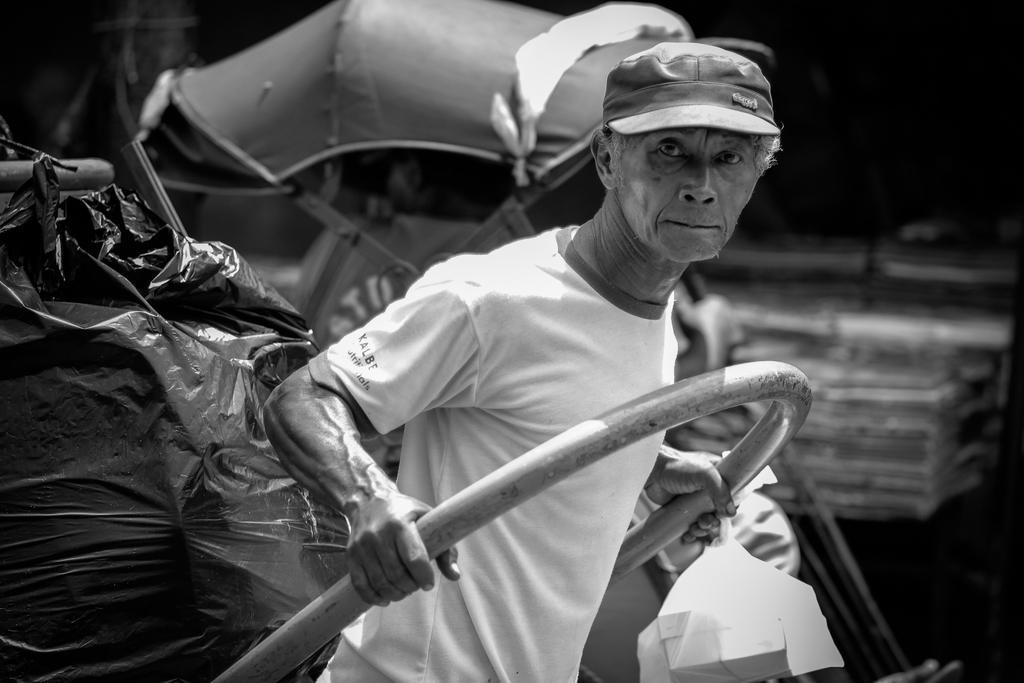Describe this image in one or two sentences. This is black and white image, in this image there is a man pulling a cart. 